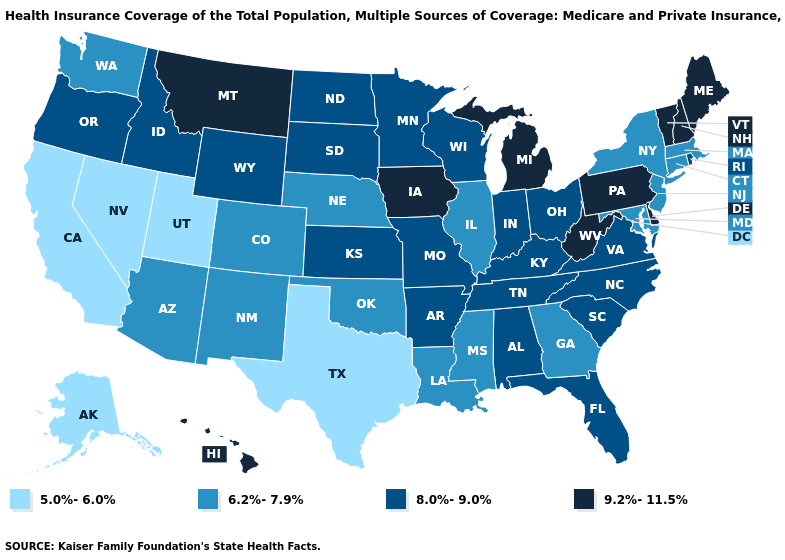Does the map have missing data?
Concise answer only. No. Name the states that have a value in the range 8.0%-9.0%?
Write a very short answer. Alabama, Arkansas, Florida, Idaho, Indiana, Kansas, Kentucky, Minnesota, Missouri, North Carolina, North Dakota, Ohio, Oregon, Rhode Island, South Carolina, South Dakota, Tennessee, Virginia, Wisconsin, Wyoming. Name the states that have a value in the range 9.2%-11.5%?
Concise answer only. Delaware, Hawaii, Iowa, Maine, Michigan, Montana, New Hampshire, Pennsylvania, Vermont, West Virginia. Does Missouri have the highest value in the MidWest?
Give a very brief answer. No. What is the highest value in states that border New Mexico?
Quick response, please. 6.2%-7.9%. Does Wyoming have the highest value in the USA?
Short answer required. No. Does Rhode Island have a lower value than Iowa?
Keep it brief. Yes. Name the states that have a value in the range 5.0%-6.0%?
Short answer required. Alaska, California, Nevada, Texas, Utah. Name the states that have a value in the range 5.0%-6.0%?
Concise answer only. Alaska, California, Nevada, Texas, Utah. What is the lowest value in the MidWest?
Write a very short answer. 6.2%-7.9%. Does Pennsylvania have a higher value than Maine?
Short answer required. No. Does New Mexico have the lowest value in the USA?
Concise answer only. No. What is the value of Mississippi?
Short answer required. 6.2%-7.9%. Does California have the lowest value in the USA?
Be succinct. Yes. 